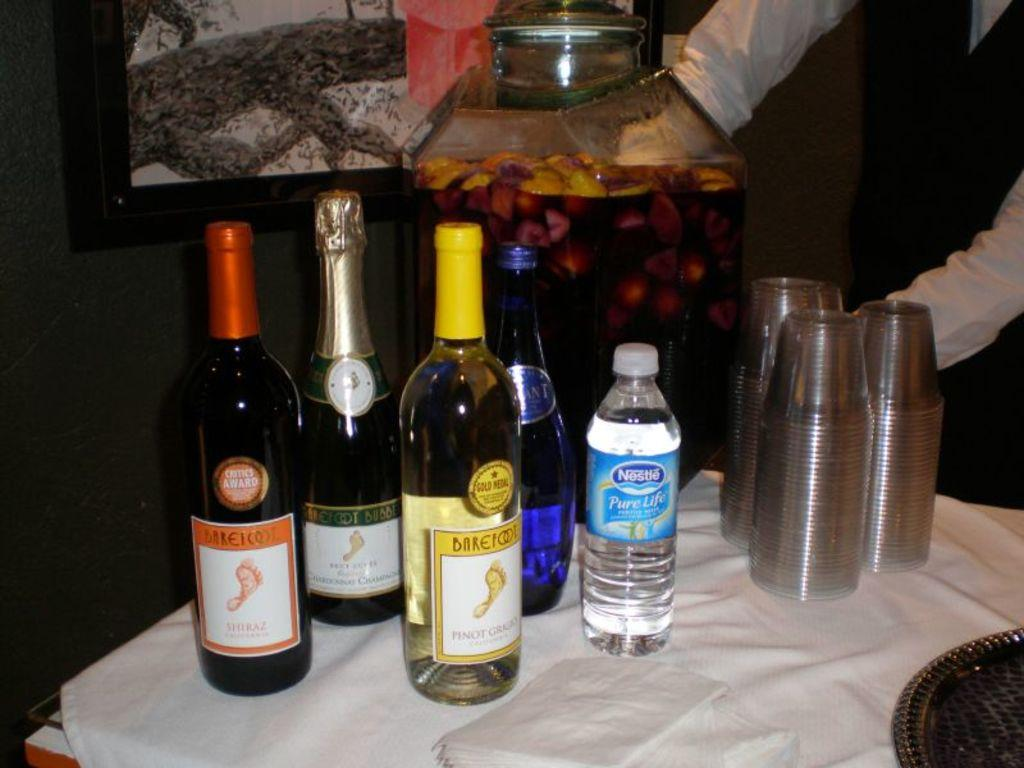<image>
Share a concise interpretation of the image provided. barefoot wine is sitting on the table with water and some cups 